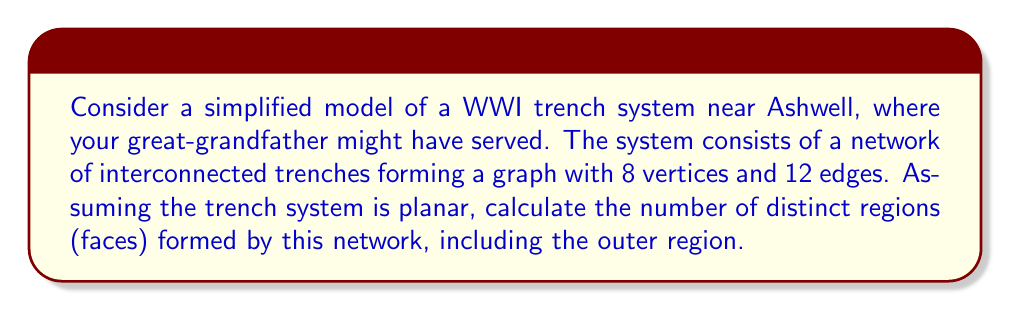Could you help me with this problem? To solve this problem, we can use Euler's formula for planar graphs:

$$V - E + F = 2$$

Where:
$V$ = number of vertices
$E$ = number of edges
$F$ = number of faces (including the outer region)

We are given:
$V = 8$ (vertices)
$E = 12$ (edges)

Let's substitute these values into Euler's formula:

$$8 - 12 + F = 2$$

Now, we can solve for $F$:

$$F = 2 - 8 + 12 = 6$$

Therefore, the trench system forms 6 distinct regions, including the outer region.

This topological analysis reveals important properties of the trench system:

1. Connectivity: The number of edges (12) compared to vertices (8) suggests a well-connected network, which was crucial for communication and movement in WWI trenches.

2. Compartmentalization: The 6 regions indicate distinct areas within the trench system, which could represent different functional zones (e.g., front line, support trenches, command posts).

3. Defensive depth: Multiple regions suggest a system with depth, a key principle in trench warfare that your great-grandfather would have experienced.

4. Planar nature: The fact that the system can be represented as a planar graph indicates that trenches didn't need to cross over each other, which was typical of WWI trench designs.
Answer: 6 regions (faces) 